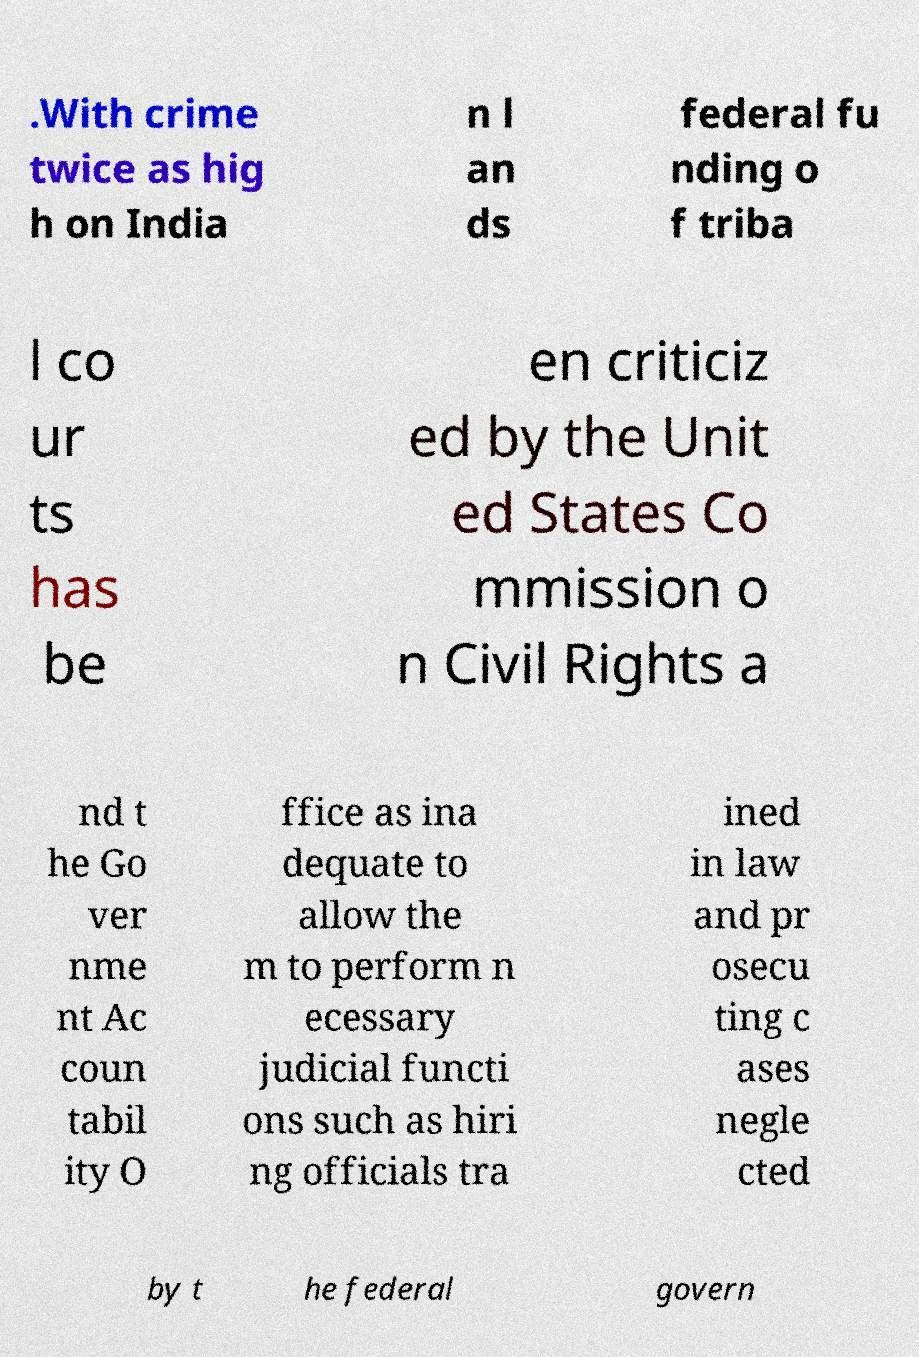Could you assist in decoding the text presented in this image and type it out clearly? .With crime twice as hig h on India n l an ds federal fu nding o f triba l co ur ts has be en criticiz ed by the Unit ed States Co mmission o n Civil Rights a nd t he Go ver nme nt Ac coun tabil ity O ffice as ina dequate to allow the m to perform n ecessary judicial functi ons such as hiri ng officials tra ined in law and pr osecu ting c ases negle cted by t he federal govern 